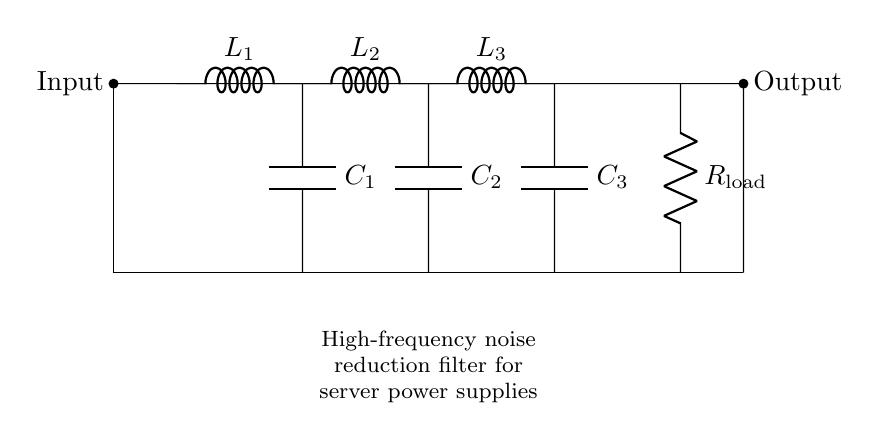What components are used in this circuit? The circuit contains inductors, capacitors, and a resistor, specifically three inductors labeled L1, L2, and L3, three capacitors labeled C1, C2, and C3, and a load resistor labeled R_load.
Answer: Inductors, capacitors, resistor What is the function of this circuit? This circuit is designed as a high-frequency noise reduction filter for server power supplies, which helps filter out unwanted high-frequency noise from the power supply signal.
Answer: High-frequency noise reduction How many inductors are present in this circuit? The diagram displays three inductors, labeled L1, L2, and L3, as connected in series.
Answer: Three What is the relationship between the inductors and the capacitors in this circuit? Inductors and capacitors in this filter work together to form a resonant circuit that helps attenuate high-frequency noise. The inductors oppose changes in current and the capacitors store and release energy, creating a frequency-dependent response.
Answer: Resonant circuit for noise attenuation What is the load connected at the output of this circuit? The output of the circuit is connected to a resistor labeled R_load, which acts as the load for the filtered signal coming from the high-frequency noise reduction filter.
Answer: Resistor R_load What would happen if one of the capacitors is removed from the circuit? If one of the capacitors is removed, the circuit's ability to filter high-frequency noise will be compromised, likely leading to increased noise on the output voltage and poor performance of the server power supply.
Answer: Compromised noise filtering Which component primarily handles high-frequency signals in this circuit? The capacitors are primarily responsible for handling and filtering high-frequency signals, as they can shunt high-frequency components to ground while allowing lower frequencies to pass through.
Answer: Capacitors 